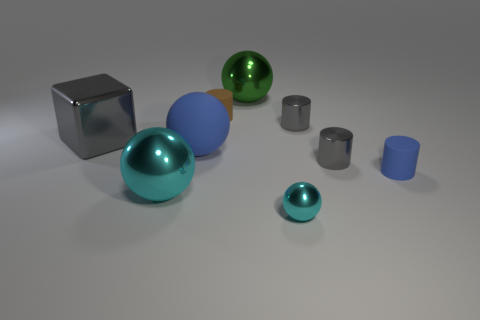Subtract all red cylinders. Subtract all brown spheres. How many cylinders are left? 4 Subtract all cylinders. How many objects are left? 5 Subtract 0 purple cylinders. How many objects are left? 9 Subtract all blue spheres. Subtract all small brown cylinders. How many objects are left? 7 Add 7 big cyan metallic balls. How many big cyan metallic balls are left? 8 Add 6 large purple matte things. How many large purple matte things exist? 6 